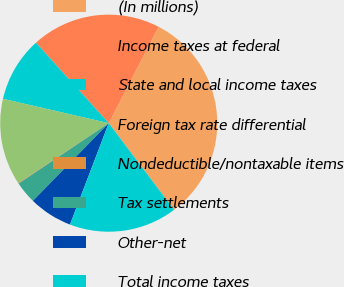Convert chart. <chart><loc_0><loc_0><loc_500><loc_500><pie_chart><fcel>(In millions)<fcel>Income taxes at federal<fcel>State and local income taxes<fcel>Foreign tax rate differential<fcel>Nondeductible/nontaxable items<fcel>Tax settlements<fcel>Other-net<fcel>Total income taxes<nl><fcel>32.11%<fcel>19.3%<fcel>9.7%<fcel>12.9%<fcel>0.09%<fcel>3.3%<fcel>6.5%<fcel>16.1%<nl></chart> 